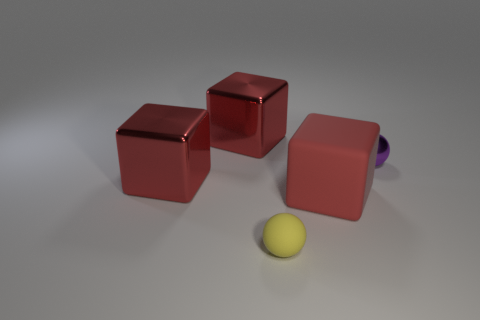Are there fewer yellow matte things than cyan metallic blocks?
Keep it short and to the point. No. Is the shape of the purple shiny object the same as the yellow matte object?
Offer a very short reply. Yes. What number of objects are small purple spheres or red things that are left of the yellow ball?
Your answer should be compact. 3. How many tiny balls are there?
Your answer should be compact. 2. Are there any blue shiny things that have the same size as the purple shiny ball?
Keep it short and to the point. No. Are there fewer small purple objects that are on the right side of the tiny metal thing than green rubber things?
Your response must be concise. No. Do the red rubber cube and the purple shiny thing have the same size?
Your answer should be compact. No. What is the size of the other thing that is made of the same material as the yellow object?
Offer a very short reply. Large. How many big metallic things are the same color as the rubber block?
Keep it short and to the point. 2. Are there fewer small matte things that are on the right side of the large red rubber object than tiny yellow rubber spheres behind the small yellow rubber thing?
Provide a short and direct response. No. 